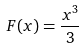Convert formula to latex. <formula><loc_0><loc_0><loc_500><loc_500>F ( x ) = \frac { x ^ { 3 } } { 3 }</formula> 